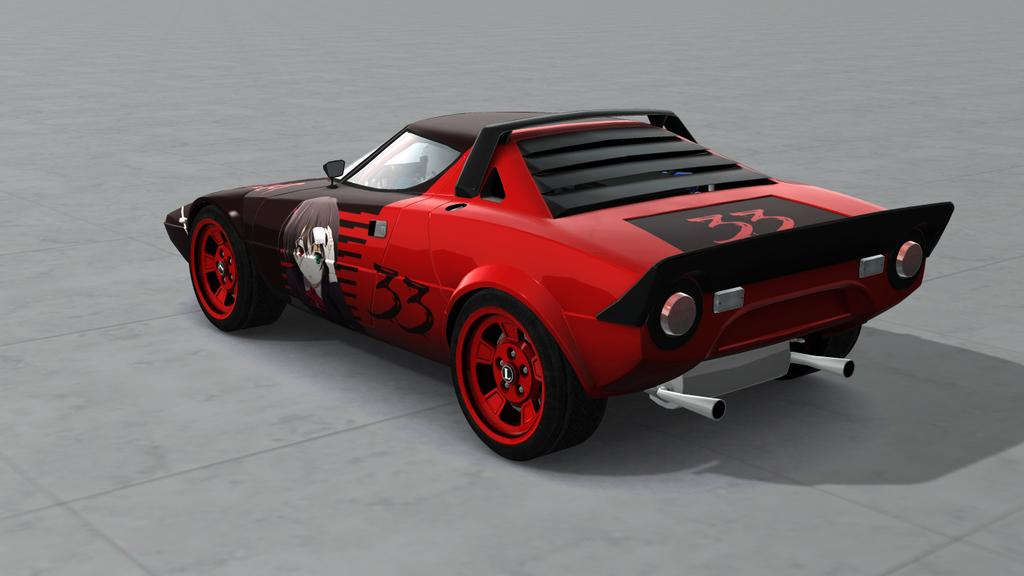What is the color of the car in the image? The car in the image is red. Where is the car located in the image? The car is on a road in the image. What type of laborer is working on the car in the image? There is no laborer present in the image, and the car is not being worked on. What date is marked on the calendar hanging in the car in the image? There is no calendar present in the image. 